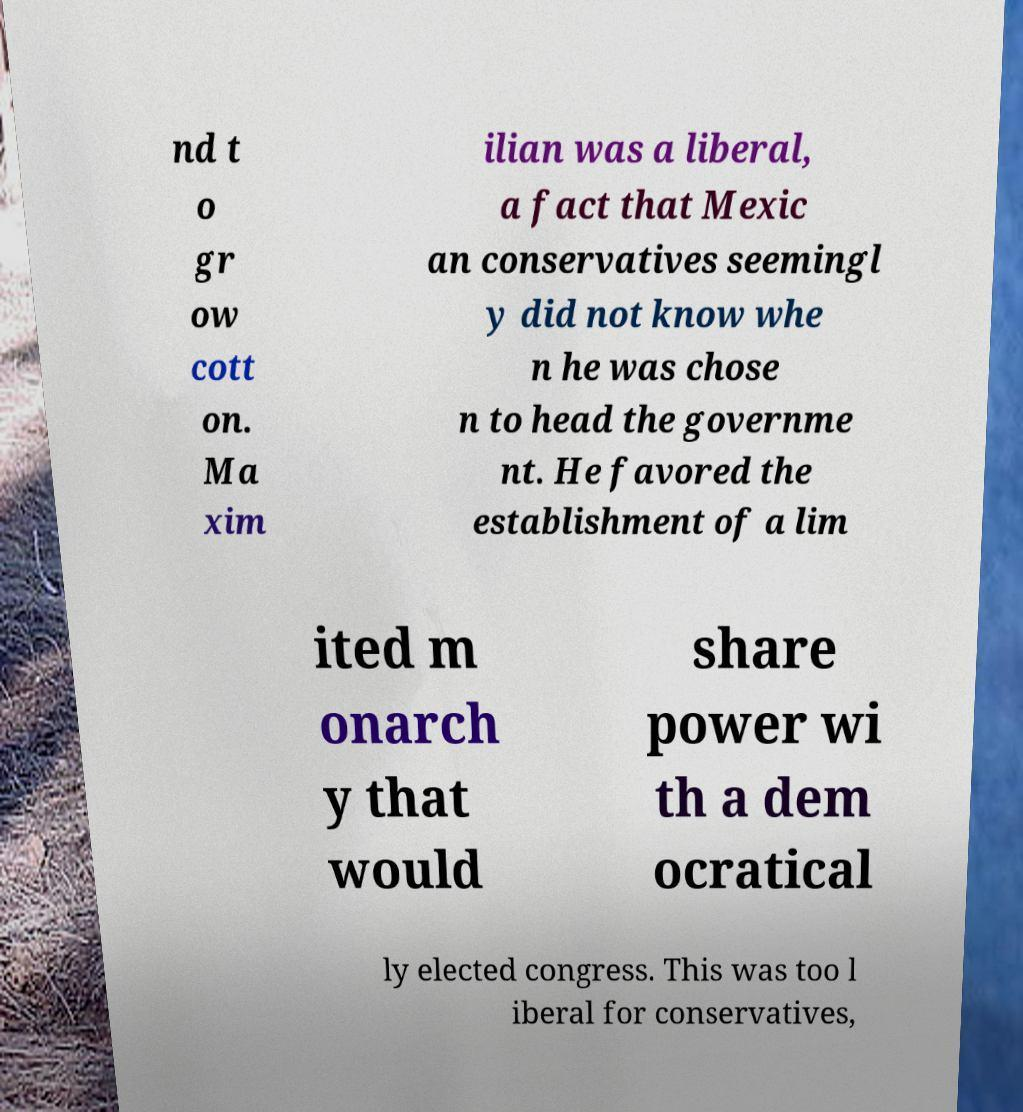Can you accurately transcribe the text from the provided image for me? nd t o gr ow cott on. Ma xim ilian was a liberal, a fact that Mexic an conservatives seemingl y did not know whe n he was chose n to head the governme nt. He favored the establishment of a lim ited m onarch y that would share power wi th a dem ocratical ly elected congress. This was too l iberal for conservatives, 